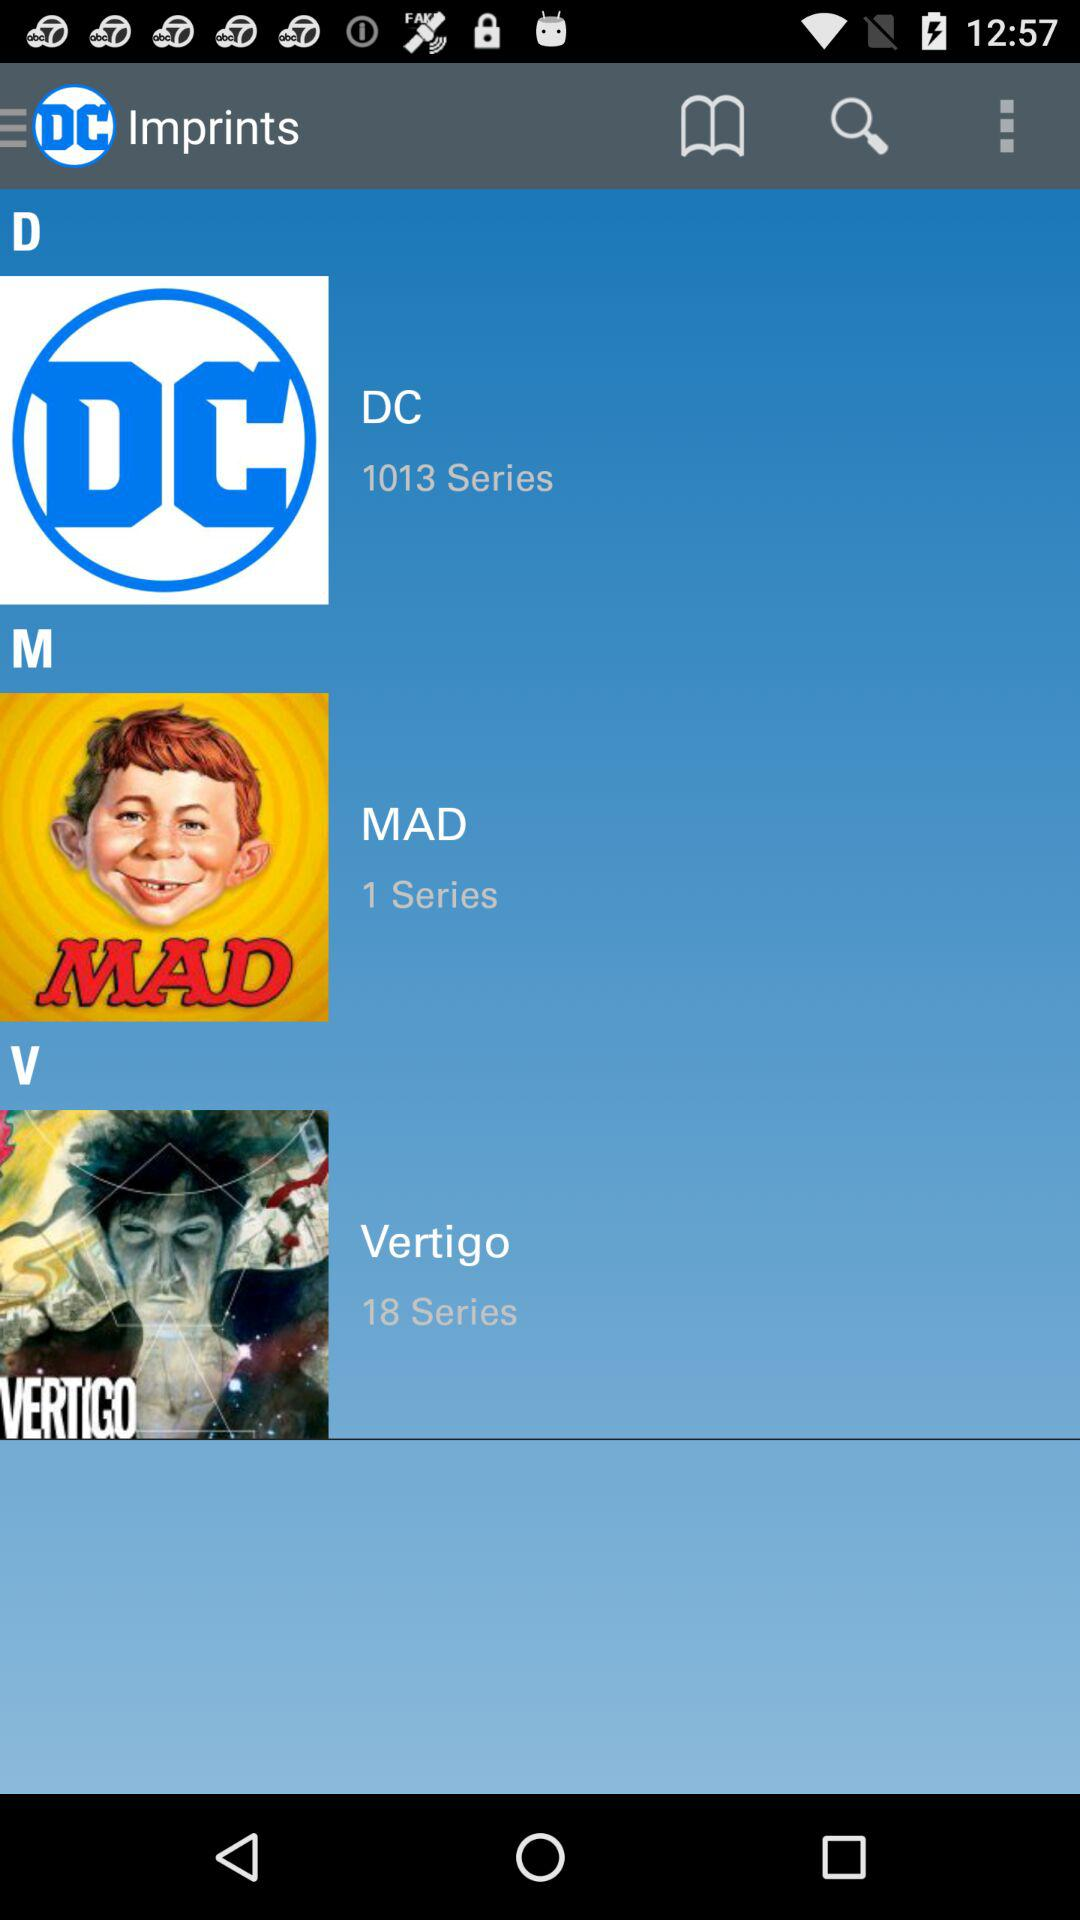How many series of "Vertigo" are there? There are 18 series of "Vertigo". 